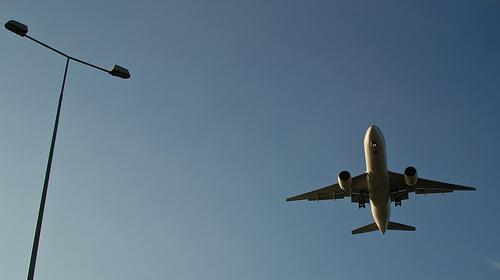How many vehicles are shown in the photo?
Give a very brief answer. 1. How many wings does the airplane have?
Give a very brief answer. 2. 